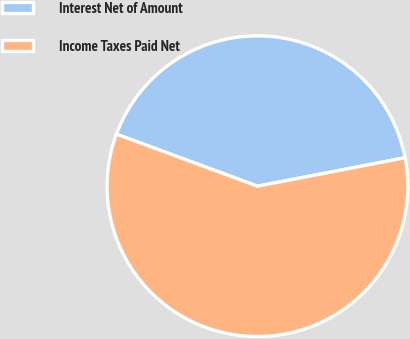<chart> <loc_0><loc_0><loc_500><loc_500><pie_chart><fcel>Interest Net of Amount<fcel>Income Taxes Paid Net<nl><fcel>41.34%<fcel>58.66%<nl></chart> 